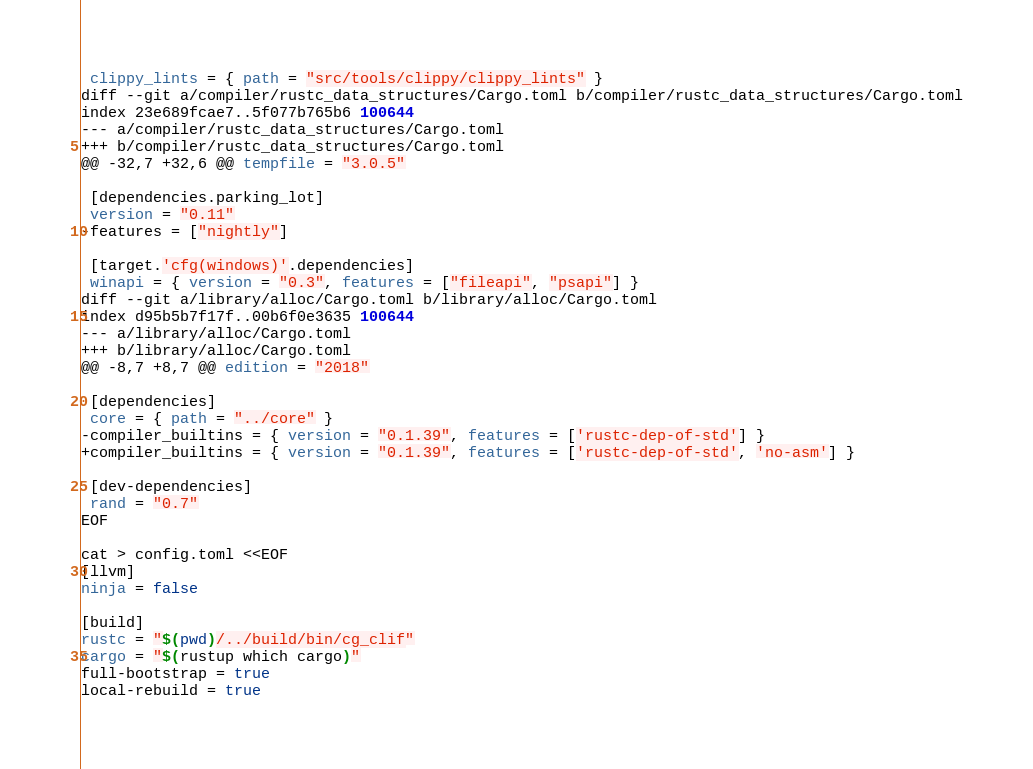Convert code to text. <code><loc_0><loc_0><loc_500><loc_500><_Bash_> clippy_lints = { path = "src/tools/clippy/clippy_lints" }
diff --git a/compiler/rustc_data_structures/Cargo.toml b/compiler/rustc_data_structures/Cargo.toml
index 23e689fcae7..5f077b765b6 100644
--- a/compiler/rustc_data_structures/Cargo.toml
+++ b/compiler/rustc_data_structures/Cargo.toml
@@ -32,7 +32,6 @@ tempfile = "3.0.5"

 [dependencies.parking_lot]
 version = "0.11"
-features = ["nightly"]

 [target.'cfg(windows)'.dependencies]
 winapi = { version = "0.3", features = ["fileapi", "psapi"] }
diff --git a/library/alloc/Cargo.toml b/library/alloc/Cargo.toml
index d95b5b7f17f..00b6f0e3635 100644
--- a/library/alloc/Cargo.toml
+++ b/library/alloc/Cargo.toml
@@ -8,7 +8,7 @@ edition = "2018"

 [dependencies]
 core = { path = "../core" }
-compiler_builtins = { version = "0.1.39", features = ['rustc-dep-of-std'] }
+compiler_builtins = { version = "0.1.39", features = ['rustc-dep-of-std', 'no-asm'] }

 [dev-dependencies]
 rand = "0.7"
EOF

cat > config.toml <<EOF
[llvm]
ninja = false

[build]
rustc = "$(pwd)/../build/bin/cg_clif"
cargo = "$(rustup which cargo)"
full-bootstrap = true
local-rebuild = true
</code> 